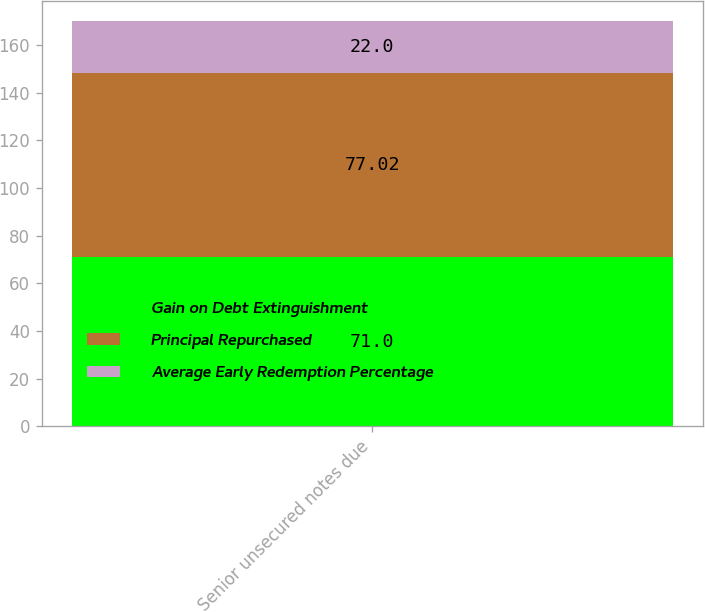Convert chart to OTSL. <chart><loc_0><loc_0><loc_500><loc_500><stacked_bar_chart><ecel><fcel>Senior unsecured notes due<nl><fcel>Gain on Debt Extinguishment<fcel>71<nl><fcel>Principal Repurchased<fcel>77.02<nl><fcel>Average Early Redemption Percentage<fcel>22<nl></chart> 